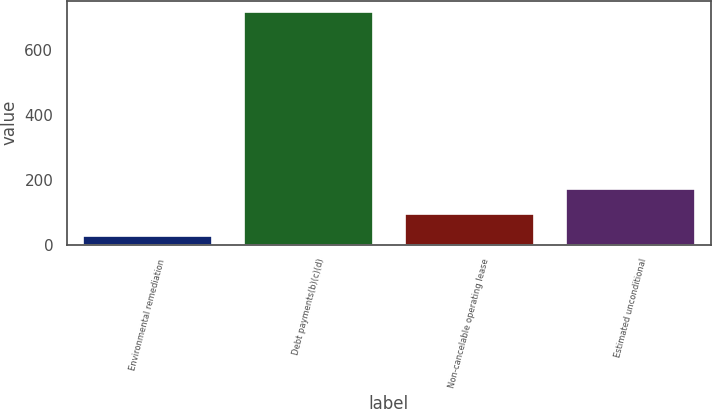Convert chart. <chart><loc_0><loc_0><loc_500><loc_500><bar_chart><fcel>Environmental remediation<fcel>Debt payments(b)(c)(d)<fcel>Non-cancelable operating lease<fcel>Estimated unconditional<nl><fcel>26<fcel>717<fcel>95.1<fcel>172<nl></chart> 